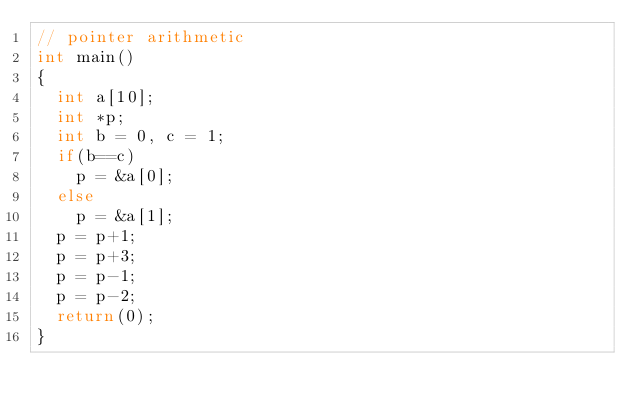Convert code to text. <code><loc_0><loc_0><loc_500><loc_500><_C_>// pointer arithmetic
int main()
{
  int a[10];
  int *p;
  int b = 0, c = 1;
  if(b==c)
    p = &a[0];
  else
    p = &a[1];
  p = p+1;
  p = p+3;
  p = p-1;
  p = p-2;
  return(0);
}
</code> 